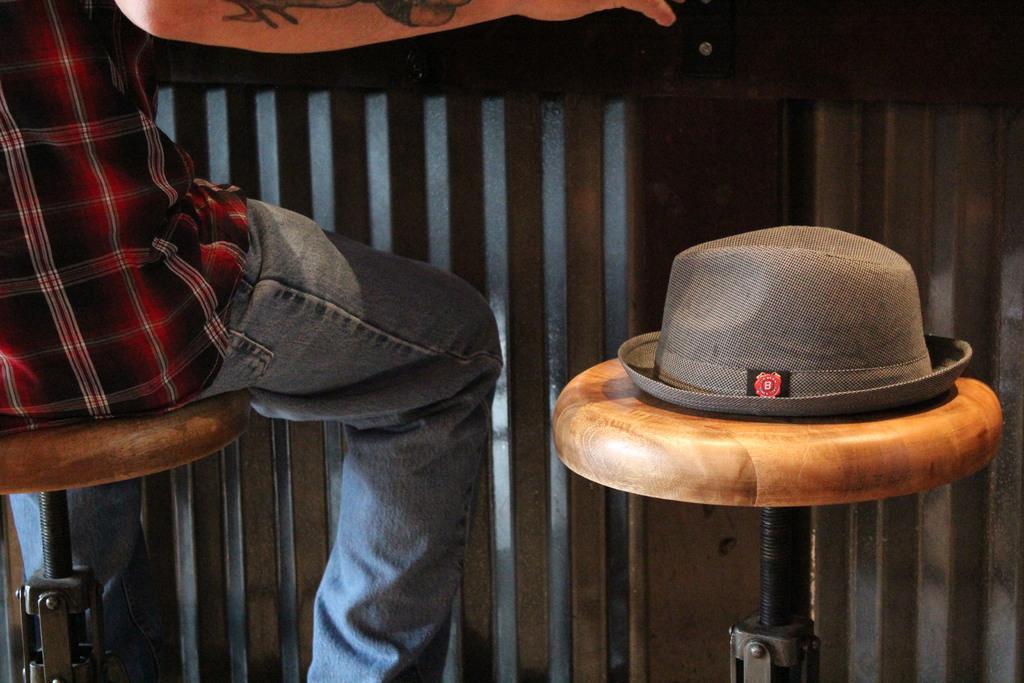Can you describe this image briefly? In this image we can see a person sitting on the seating stool and a hat on the another seating stool. 